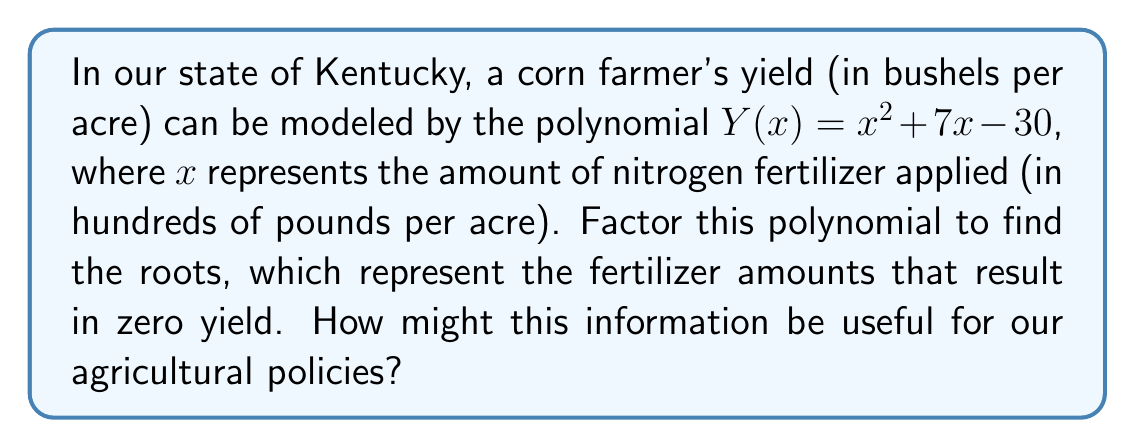Teach me how to tackle this problem. Let's factor the polynomial $Y(x) = x^2 + 7x - 30$ step by step:

1) First, we recognize this as a quadratic equation in the form $ax^2 + bx + c$, where $a=1$, $b=7$, and $c=-30$.

2) To factor this, we need to find two numbers that multiply to give $ac = 1 \times (-30) = -30$ and add up to $b = 7$.

3) The factors of -30 are: $\pm 1, \pm 2, \pm 3, \pm 5, \pm 6, \pm 10, \pm 15, \pm 30$

4) By inspection or trial and error, we find that $10$ and $-3$ work: $10 + (-3) = 7$ and $10 \times (-3) = -30$

5) We can rewrite the middle term using these numbers:
   $Y(x) = x^2 + 10x - 3x - 30$

6) Now we can factor by grouping:
   $Y(x) = (x^2 + 10x) + (-3x - 30)$
   $Y(x) = x(x + 10) - 3(x + 10)$
   $Y(x) = (x - 3)(x + 10)$

7) The roots of the polynomial are the values of $x$ that make $Y(x) = 0$. This occurs when either $(x - 3) = 0$ or $(x + 10) = 0$.

8) Solving these:
   $x - 3 = 0$ gives $x = 3$
   $x + 10 = 0$ gives $x = -10$

Therefore, the roots are $x = 3$ and $x = -10$. In the context of the problem, $x = 3$ means 300 pounds of fertilizer per acre, while $x = -10$ is not practically meaningful (we can't apply negative fertilizer).

This information could be useful for agricultural policies by helping to set guidelines for fertilizer use. It suggests that yields increase with fertilizer use up to 300 pounds per acre, after which they may decrease due to over-fertilization.
Answer: $(x - 3)(x + 10)$ 